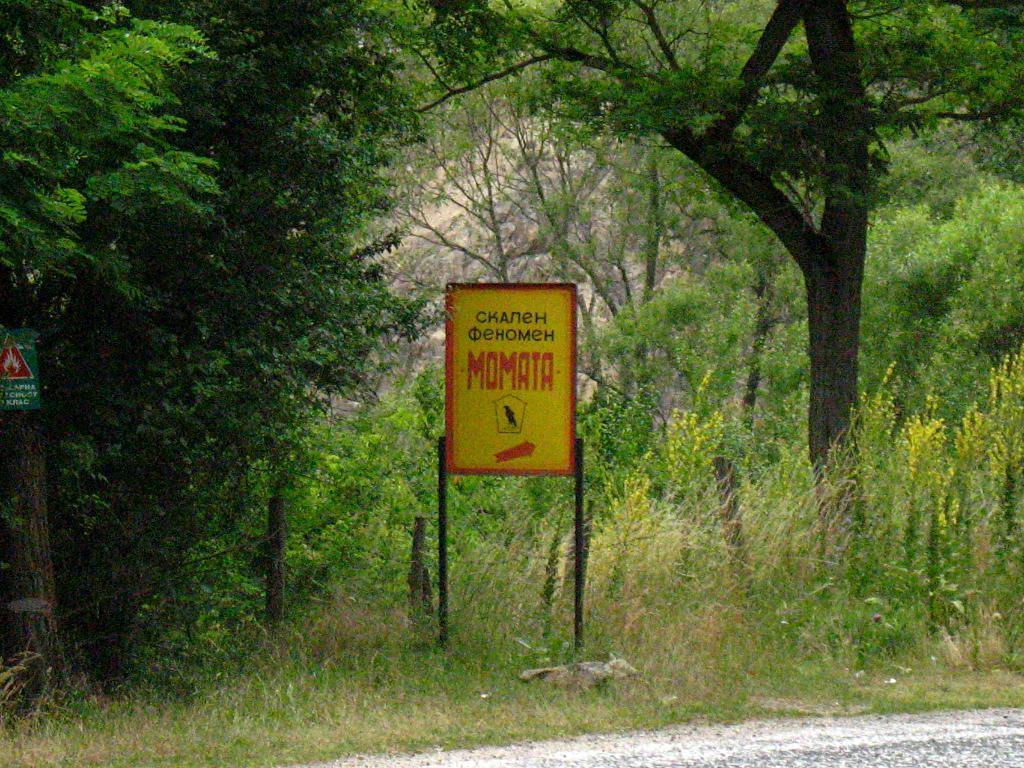What does the sign say?
Offer a very short reply. Momata. 